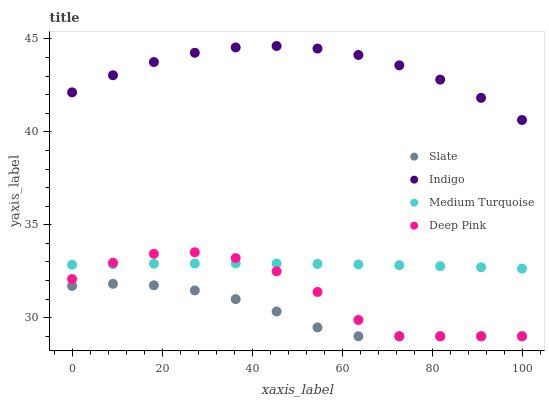Does Slate have the minimum area under the curve?
Answer yes or no. Yes. Does Indigo have the maximum area under the curve?
Answer yes or no. Yes. Does Deep Pink have the minimum area under the curve?
Answer yes or no. No. Does Deep Pink have the maximum area under the curve?
Answer yes or no. No. Is Medium Turquoise the smoothest?
Answer yes or no. Yes. Is Deep Pink the roughest?
Answer yes or no. Yes. Is Indigo the smoothest?
Answer yes or no. No. Is Indigo the roughest?
Answer yes or no. No. Does Slate have the lowest value?
Answer yes or no. Yes. Does Indigo have the lowest value?
Answer yes or no. No. Does Indigo have the highest value?
Answer yes or no. Yes. Does Deep Pink have the highest value?
Answer yes or no. No. Is Medium Turquoise less than Indigo?
Answer yes or no. Yes. Is Indigo greater than Slate?
Answer yes or no. Yes. Does Slate intersect Deep Pink?
Answer yes or no. Yes. Is Slate less than Deep Pink?
Answer yes or no. No. Is Slate greater than Deep Pink?
Answer yes or no. No. Does Medium Turquoise intersect Indigo?
Answer yes or no. No. 